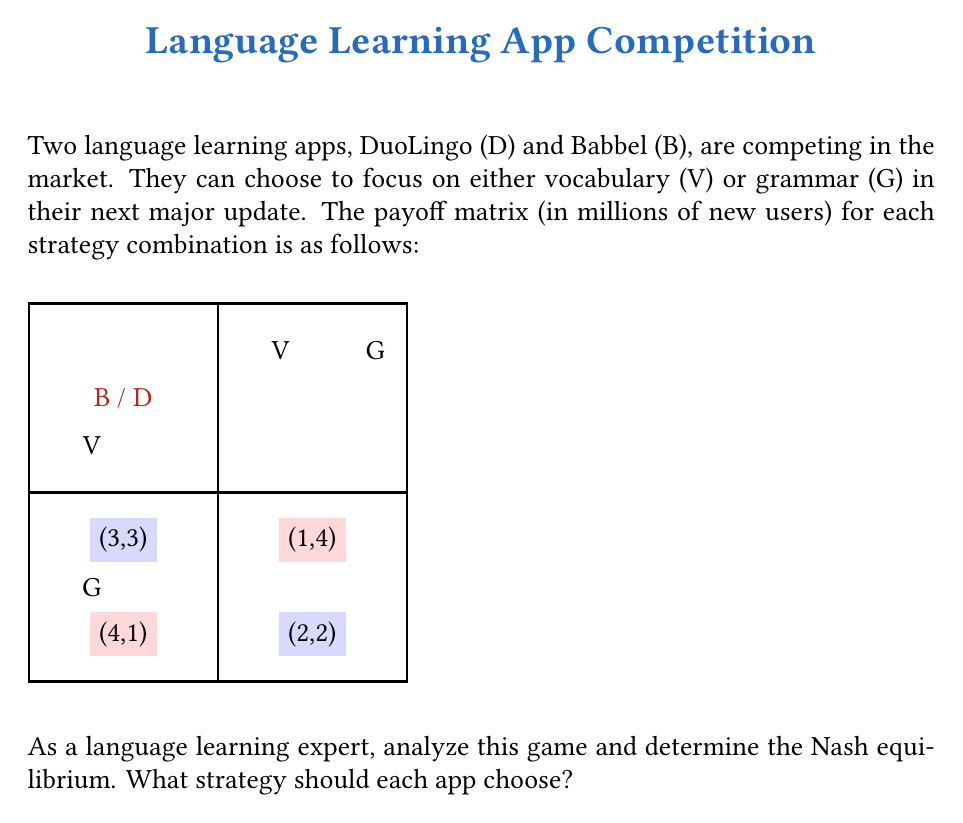Show me your answer to this math problem. To find the Nash equilibrium, we need to analyze each player's best response to the other player's strategy:

1. For DuoLingo (D):
   - If Babbel chooses V, D's best response is V (3 > 1)
   - If Babbel chooses G, D's best response is V (4 > 2)

2. For Babbel (B):
   - If DuoLingo chooses V, B's best response is V (3 > 1)
   - If DuoLingo chooses G, B's best response is V (4 > 2)

A Nash equilibrium occurs when each player is making the best decision for themselves, given what the other player is doing. In this case, we can see that (V,V) is a Nash equilibrium because:

- If D switches to G while B stays at V, D's payoff decreases from 3 to 1
- If B switches to G while D stays at V, B's payoff decreases from 3 to 1

We can confirm this mathematically:

Let $p$ be the probability that DuoLingo chooses V, and $q$ be the probability that Babbel chooses V.

For DuoLingo:
$$E(V) = 3q + 4(1-q) = 4 - q$$
$$E(G) = q + 2(1-q) = 2 - q$$

$E(V) > E(G)$ for all $q$, so DuoLingo always prefers V.

For Babbel:
$$E(V) = 3p + 4(1-p) = 4 - p$$
$$E(G) = p + 2(1-p) = 2 - p$$

$E(V) > E(G)$ for all $p$, so Babbel always prefers V.

Therefore, (V,V) is the unique Nash equilibrium in this game.
Answer: (V,V) 